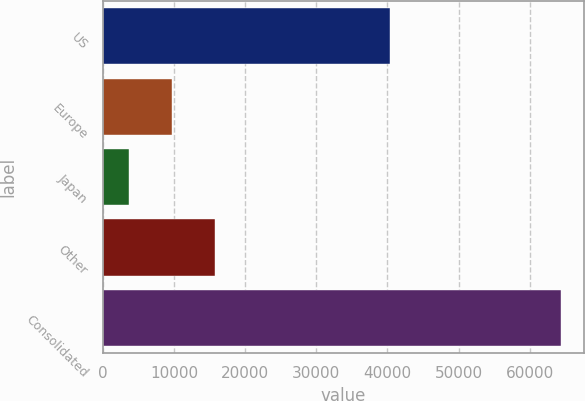<chart> <loc_0><loc_0><loc_500><loc_500><bar_chart><fcel>US<fcel>Europe<fcel>Japan<fcel>Other<fcel>Consolidated<nl><fcel>40291<fcel>9717.5<fcel>3641<fcel>15794<fcel>64406<nl></chart> 